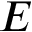Convert formula to latex. <formula><loc_0><loc_0><loc_500><loc_500>E</formula> 